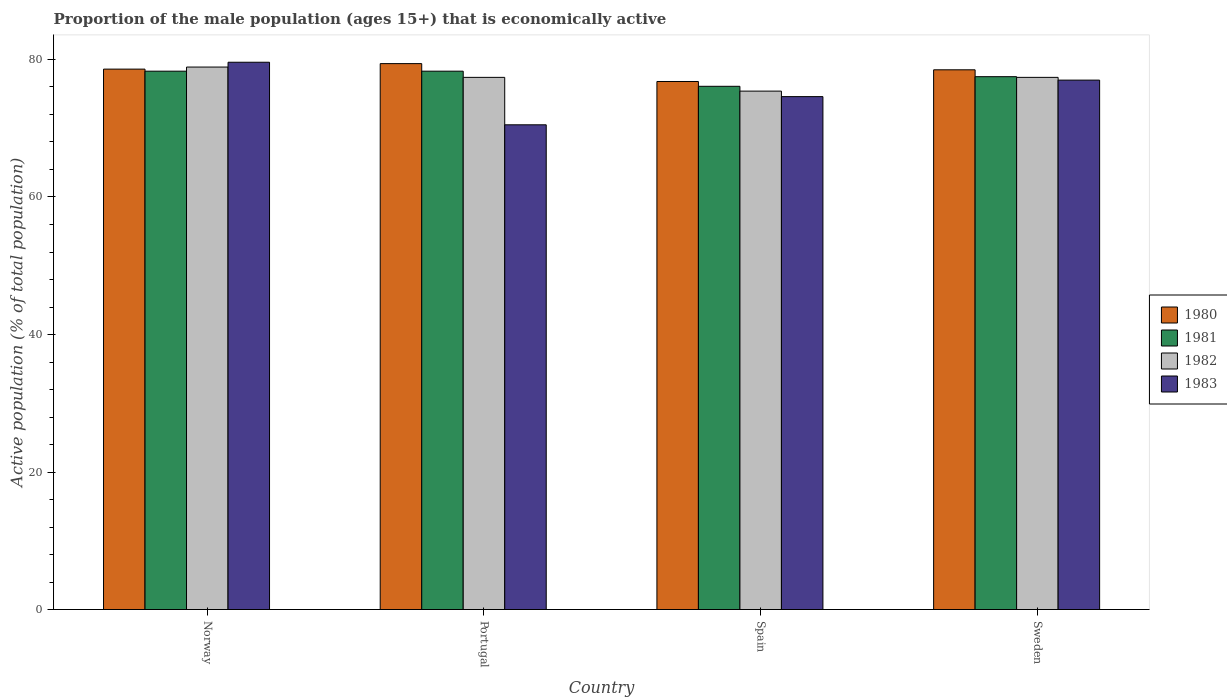How many groups of bars are there?
Your answer should be compact. 4. Are the number of bars per tick equal to the number of legend labels?
Provide a short and direct response. Yes. How many bars are there on the 4th tick from the right?
Provide a succinct answer. 4. What is the label of the 3rd group of bars from the left?
Provide a short and direct response. Spain. What is the proportion of the male population that is economically active in 1982 in Portugal?
Offer a very short reply. 77.4. Across all countries, what is the maximum proportion of the male population that is economically active in 1981?
Your answer should be compact. 78.3. Across all countries, what is the minimum proportion of the male population that is economically active in 1982?
Your response must be concise. 75.4. What is the total proportion of the male population that is economically active in 1982 in the graph?
Give a very brief answer. 309.1. What is the difference between the proportion of the male population that is economically active in 1980 in Norway and that in Portugal?
Give a very brief answer. -0.8. What is the difference between the proportion of the male population that is economically active in 1982 in Sweden and the proportion of the male population that is economically active in 1983 in Norway?
Keep it short and to the point. -2.2. What is the average proportion of the male population that is economically active in 1983 per country?
Offer a terse response. 75.42. What is the difference between the proportion of the male population that is economically active of/in 1982 and proportion of the male population that is economically active of/in 1981 in Spain?
Give a very brief answer. -0.7. In how many countries, is the proportion of the male population that is economically active in 1983 greater than 48 %?
Make the answer very short. 4. What is the ratio of the proportion of the male population that is economically active in 1983 in Spain to that in Sweden?
Your answer should be very brief. 0.97. Is the proportion of the male population that is economically active in 1980 in Portugal less than that in Spain?
Keep it short and to the point. No. What is the difference between the highest and the second highest proportion of the male population that is economically active in 1980?
Provide a succinct answer. -0.1. What is the difference between the highest and the lowest proportion of the male population that is economically active in 1980?
Ensure brevity in your answer.  2.6. In how many countries, is the proportion of the male population that is economically active in 1982 greater than the average proportion of the male population that is economically active in 1982 taken over all countries?
Ensure brevity in your answer.  3. Is the sum of the proportion of the male population that is economically active in 1983 in Spain and Sweden greater than the maximum proportion of the male population that is economically active in 1981 across all countries?
Ensure brevity in your answer.  Yes. What does the 1st bar from the left in Sweden represents?
Provide a short and direct response. 1980. What does the 2nd bar from the right in Norway represents?
Ensure brevity in your answer.  1982. How many countries are there in the graph?
Make the answer very short. 4. What is the difference between two consecutive major ticks on the Y-axis?
Offer a terse response. 20. Does the graph contain any zero values?
Offer a terse response. No. Does the graph contain grids?
Your response must be concise. No. Where does the legend appear in the graph?
Your response must be concise. Center right. What is the title of the graph?
Your response must be concise. Proportion of the male population (ages 15+) that is economically active. Does "1987" appear as one of the legend labels in the graph?
Give a very brief answer. No. What is the label or title of the Y-axis?
Your answer should be compact. Active population (% of total population). What is the Active population (% of total population) of 1980 in Norway?
Your response must be concise. 78.6. What is the Active population (% of total population) in 1981 in Norway?
Provide a succinct answer. 78.3. What is the Active population (% of total population) in 1982 in Norway?
Your answer should be compact. 78.9. What is the Active population (% of total population) of 1983 in Norway?
Keep it short and to the point. 79.6. What is the Active population (% of total population) in 1980 in Portugal?
Ensure brevity in your answer.  79.4. What is the Active population (% of total population) in 1981 in Portugal?
Your response must be concise. 78.3. What is the Active population (% of total population) of 1982 in Portugal?
Your answer should be very brief. 77.4. What is the Active population (% of total population) of 1983 in Portugal?
Offer a terse response. 70.5. What is the Active population (% of total population) of 1980 in Spain?
Make the answer very short. 76.8. What is the Active population (% of total population) in 1981 in Spain?
Give a very brief answer. 76.1. What is the Active population (% of total population) in 1982 in Spain?
Your answer should be very brief. 75.4. What is the Active population (% of total population) of 1983 in Spain?
Your answer should be compact. 74.6. What is the Active population (% of total population) in 1980 in Sweden?
Provide a short and direct response. 78.5. What is the Active population (% of total population) of 1981 in Sweden?
Your answer should be very brief. 77.5. What is the Active population (% of total population) in 1982 in Sweden?
Give a very brief answer. 77.4. What is the Active population (% of total population) of 1983 in Sweden?
Offer a terse response. 77. Across all countries, what is the maximum Active population (% of total population) in 1980?
Offer a very short reply. 79.4. Across all countries, what is the maximum Active population (% of total population) in 1981?
Offer a terse response. 78.3. Across all countries, what is the maximum Active population (% of total population) in 1982?
Offer a very short reply. 78.9. Across all countries, what is the maximum Active population (% of total population) in 1983?
Make the answer very short. 79.6. Across all countries, what is the minimum Active population (% of total population) of 1980?
Your answer should be compact. 76.8. Across all countries, what is the minimum Active population (% of total population) of 1981?
Your answer should be compact. 76.1. Across all countries, what is the minimum Active population (% of total population) of 1982?
Your response must be concise. 75.4. Across all countries, what is the minimum Active population (% of total population) of 1983?
Your response must be concise. 70.5. What is the total Active population (% of total population) in 1980 in the graph?
Your answer should be compact. 313.3. What is the total Active population (% of total population) of 1981 in the graph?
Your response must be concise. 310.2. What is the total Active population (% of total population) of 1982 in the graph?
Ensure brevity in your answer.  309.1. What is the total Active population (% of total population) in 1983 in the graph?
Your answer should be compact. 301.7. What is the difference between the Active population (% of total population) of 1981 in Norway and that in Portugal?
Offer a very short reply. 0. What is the difference between the Active population (% of total population) in 1982 in Norway and that in Portugal?
Ensure brevity in your answer.  1.5. What is the difference between the Active population (% of total population) in 1980 in Norway and that in Spain?
Ensure brevity in your answer.  1.8. What is the difference between the Active population (% of total population) in 1981 in Norway and that in Spain?
Your response must be concise. 2.2. What is the difference between the Active population (% of total population) in 1982 in Norway and that in Spain?
Give a very brief answer. 3.5. What is the difference between the Active population (% of total population) of 1980 in Norway and that in Sweden?
Make the answer very short. 0.1. What is the difference between the Active population (% of total population) in 1981 in Norway and that in Sweden?
Provide a short and direct response. 0.8. What is the difference between the Active population (% of total population) of 1983 in Norway and that in Sweden?
Keep it short and to the point. 2.6. What is the difference between the Active population (% of total population) in 1981 in Portugal and that in Spain?
Your answer should be compact. 2.2. What is the difference between the Active population (% of total population) in 1983 in Portugal and that in Spain?
Your answer should be compact. -4.1. What is the difference between the Active population (% of total population) of 1982 in Portugal and that in Sweden?
Your answer should be compact. 0. What is the difference between the Active population (% of total population) in 1983 in Portugal and that in Sweden?
Your response must be concise. -6.5. What is the difference between the Active population (% of total population) in 1981 in Spain and that in Sweden?
Offer a very short reply. -1.4. What is the difference between the Active population (% of total population) of 1983 in Spain and that in Sweden?
Give a very brief answer. -2.4. What is the difference between the Active population (% of total population) of 1980 in Norway and the Active population (% of total population) of 1982 in Portugal?
Give a very brief answer. 1.2. What is the difference between the Active population (% of total population) of 1981 in Norway and the Active population (% of total population) of 1982 in Portugal?
Your answer should be compact. 0.9. What is the difference between the Active population (% of total population) in 1980 in Norway and the Active population (% of total population) in 1981 in Spain?
Offer a very short reply. 2.5. What is the difference between the Active population (% of total population) of 1980 in Norway and the Active population (% of total population) of 1983 in Spain?
Make the answer very short. 4. What is the difference between the Active population (% of total population) of 1981 in Norway and the Active population (% of total population) of 1982 in Spain?
Keep it short and to the point. 2.9. What is the difference between the Active population (% of total population) of 1982 in Norway and the Active population (% of total population) of 1983 in Spain?
Your answer should be compact. 4.3. What is the difference between the Active population (% of total population) in 1980 in Norway and the Active population (% of total population) in 1983 in Sweden?
Offer a terse response. 1.6. What is the difference between the Active population (% of total population) of 1982 in Norway and the Active population (% of total population) of 1983 in Sweden?
Provide a short and direct response. 1.9. What is the difference between the Active population (% of total population) of 1981 in Portugal and the Active population (% of total population) of 1982 in Spain?
Keep it short and to the point. 2.9. What is the difference between the Active population (% of total population) of 1981 in Portugal and the Active population (% of total population) of 1983 in Spain?
Keep it short and to the point. 3.7. What is the difference between the Active population (% of total population) in 1982 in Portugal and the Active population (% of total population) in 1983 in Spain?
Give a very brief answer. 2.8. What is the difference between the Active population (% of total population) of 1980 in Portugal and the Active population (% of total population) of 1981 in Sweden?
Give a very brief answer. 1.9. What is the difference between the Active population (% of total population) of 1980 in Portugal and the Active population (% of total population) of 1983 in Sweden?
Provide a short and direct response. 2.4. What is the difference between the Active population (% of total population) in 1981 in Portugal and the Active population (% of total population) in 1982 in Sweden?
Ensure brevity in your answer.  0.9. What is the difference between the Active population (% of total population) in 1981 in Portugal and the Active population (% of total population) in 1983 in Sweden?
Offer a very short reply. 1.3. What is the difference between the Active population (% of total population) in 1982 in Portugal and the Active population (% of total population) in 1983 in Sweden?
Offer a terse response. 0.4. What is the difference between the Active population (% of total population) in 1980 in Spain and the Active population (% of total population) in 1983 in Sweden?
Provide a succinct answer. -0.2. What is the difference between the Active population (% of total population) in 1981 in Spain and the Active population (% of total population) in 1983 in Sweden?
Ensure brevity in your answer.  -0.9. What is the difference between the Active population (% of total population) of 1982 in Spain and the Active population (% of total population) of 1983 in Sweden?
Ensure brevity in your answer.  -1.6. What is the average Active population (% of total population) of 1980 per country?
Offer a terse response. 78.33. What is the average Active population (% of total population) of 1981 per country?
Keep it short and to the point. 77.55. What is the average Active population (% of total population) of 1982 per country?
Ensure brevity in your answer.  77.28. What is the average Active population (% of total population) of 1983 per country?
Offer a terse response. 75.42. What is the difference between the Active population (% of total population) of 1980 and Active population (% of total population) of 1981 in Norway?
Your answer should be compact. 0.3. What is the difference between the Active population (% of total population) of 1980 and Active population (% of total population) of 1982 in Norway?
Your answer should be compact. -0.3. What is the difference between the Active population (% of total population) of 1980 and Active population (% of total population) of 1983 in Norway?
Provide a succinct answer. -1. What is the difference between the Active population (% of total population) in 1981 and Active population (% of total population) in 1982 in Norway?
Offer a terse response. -0.6. What is the difference between the Active population (% of total population) in 1981 and Active population (% of total population) in 1983 in Norway?
Your answer should be compact. -1.3. What is the difference between the Active population (% of total population) in 1980 and Active population (% of total population) in 1981 in Portugal?
Your answer should be very brief. 1.1. What is the difference between the Active population (% of total population) in 1982 and Active population (% of total population) in 1983 in Portugal?
Give a very brief answer. 6.9. What is the difference between the Active population (% of total population) in 1980 and Active population (% of total population) in 1981 in Spain?
Offer a very short reply. 0.7. What is the difference between the Active population (% of total population) in 1980 and Active population (% of total population) in 1983 in Spain?
Keep it short and to the point. 2.2. What is the difference between the Active population (% of total population) of 1981 and Active population (% of total population) of 1983 in Spain?
Provide a succinct answer. 1.5. What is the difference between the Active population (% of total population) in 1980 and Active population (% of total population) in 1981 in Sweden?
Give a very brief answer. 1. What is the difference between the Active population (% of total population) in 1980 and Active population (% of total population) in 1982 in Sweden?
Provide a succinct answer. 1.1. What is the ratio of the Active population (% of total population) in 1980 in Norway to that in Portugal?
Ensure brevity in your answer.  0.99. What is the ratio of the Active population (% of total population) in 1981 in Norway to that in Portugal?
Make the answer very short. 1. What is the ratio of the Active population (% of total population) in 1982 in Norway to that in Portugal?
Offer a very short reply. 1.02. What is the ratio of the Active population (% of total population) of 1983 in Norway to that in Portugal?
Your response must be concise. 1.13. What is the ratio of the Active population (% of total population) in 1980 in Norway to that in Spain?
Your answer should be very brief. 1.02. What is the ratio of the Active population (% of total population) in 1981 in Norway to that in Spain?
Provide a succinct answer. 1.03. What is the ratio of the Active population (% of total population) of 1982 in Norway to that in Spain?
Ensure brevity in your answer.  1.05. What is the ratio of the Active population (% of total population) in 1983 in Norway to that in Spain?
Your answer should be very brief. 1.07. What is the ratio of the Active population (% of total population) of 1980 in Norway to that in Sweden?
Provide a succinct answer. 1. What is the ratio of the Active population (% of total population) of 1981 in Norway to that in Sweden?
Ensure brevity in your answer.  1.01. What is the ratio of the Active population (% of total population) in 1982 in Norway to that in Sweden?
Offer a terse response. 1.02. What is the ratio of the Active population (% of total population) of 1983 in Norway to that in Sweden?
Give a very brief answer. 1.03. What is the ratio of the Active population (% of total population) of 1980 in Portugal to that in Spain?
Give a very brief answer. 1.03. What is the ratio of the Active population (% of total population) in 1981 in Portugal to that in Spain?
Your answer should be compact. 1.03. What is the ratio of the Active population (% of total population) of 1982 in Portugal to that in Spain?
Keep it short and to the point. 1.03. What is the ratio of the Active population (% of total population) in 1983 in Portugal to that in Spain?
Provide a short and direct response. 0.94. What is the ratio of the Active population (% of total population) in 1980 in Portugal to that in Sweden?
Provide a succinct answer. 1.01. What is the ratio of the Active population (% of total population) in 1981 in Portugal to that in Sweden?
Offer a terse response. 1.01. What is the ratio of the Active population (% of total population) of 1982 in Portugal to that in Sweden?
Offer a terse response. 1. What is the ratio of the Active population (% of total population) of 1983 in Portugal to that in Sweden?
Give a very brief answer. 0.92. What is the ratio of the Active population (% of total population) in 1980 in Spain to that in Sweden?
Your answer should be compact. 0.98. What is the ratio of the Active population (% of total population) in 1981 in Spain to that in Sweden?
Your response must be concise. 0.98. What is the ratio of the Active population (% of total population) in 1982 in Spain to that in Sweden?
Provide a succinct answer. 0.97. What is the ratio of the Active population (% of total population) of 1983 in Spain to that in Sweden?
Provide a succinct answer. 0.97. What is the difference between the highest and the second highest Active population (% of total population) of 1980?
Keep it short and to the point. 0.8. What is the difference between the highest and the second highest Active population (% of total population) in 1982?
Give a very brief answer. 1.5. What is the difference between the highest and the second highest Active population (% of total population) in 1983?
Your response must be concise. 2.6. What is the difference between the highest and the lowest Active population (% of total population) of 1981?
Provide a succinct answer. 2.2. What is the difference between the highest and the lowest Active population (% of total population) of 1982?
Make the answer very short. 3.5. What is the difference between the highest and the lowest Active population (% of total population) in 1983?
Your answer should be compact. 9.1. 